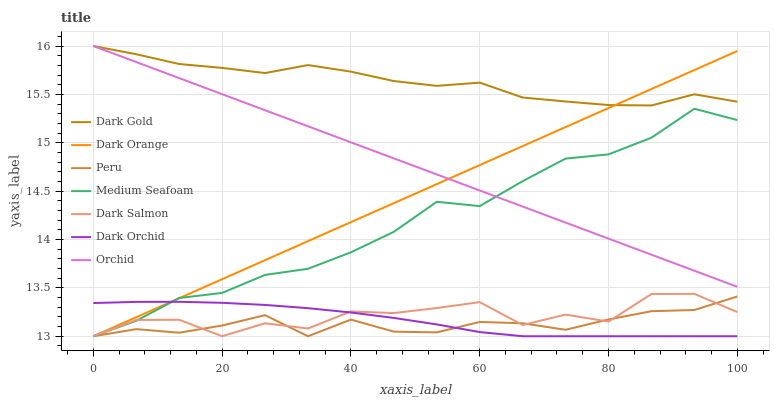Does Peru have the minimum area under the curve?
Answer yes or no. Yes. Does Dark Gold have the maximum area under the curve?
Answer yes or no. Yes. Does Dark Salmon have the minimum area under the curve?
Answer yes or no. No. Does Dark Salmon have the maximum area under the curve?
Answer yes or no. No. Is Orchid the smoothest?
Answer yes or no. Yes. Is Dark Salmon the roughest?
Answer yes or no. Yes. Is Dark Gold the smoothest?
Answer yes or no. No. Is Dark Gold the roughest?
Answer yes or no. No. Does Dark Orange have the lowest value?
Answer yes or no. Yes. Does Dark Gold have the lowest value?
Answer yes or no. No. Does Orchid have the highest value?
Answer yes or no. Yes. Does Dark Salmon have the highest value?
Answer yes or no. No. Is Peru less than Orchid?
Answer yes or no. Yes. Is Dark Gold greater than Dark Orchid?
Answer yes or no. Yes. Does Dark Orange intersect Dark Gold?
Answer yes or no. Yes. Is Dark Orange less than Dark Gold?
Answer yes or no. No. Is Dark Orange greater than Dark Gold?
Answer yes or no. No. Does Peru intersect Orchid?
Answer yes or no. No. 